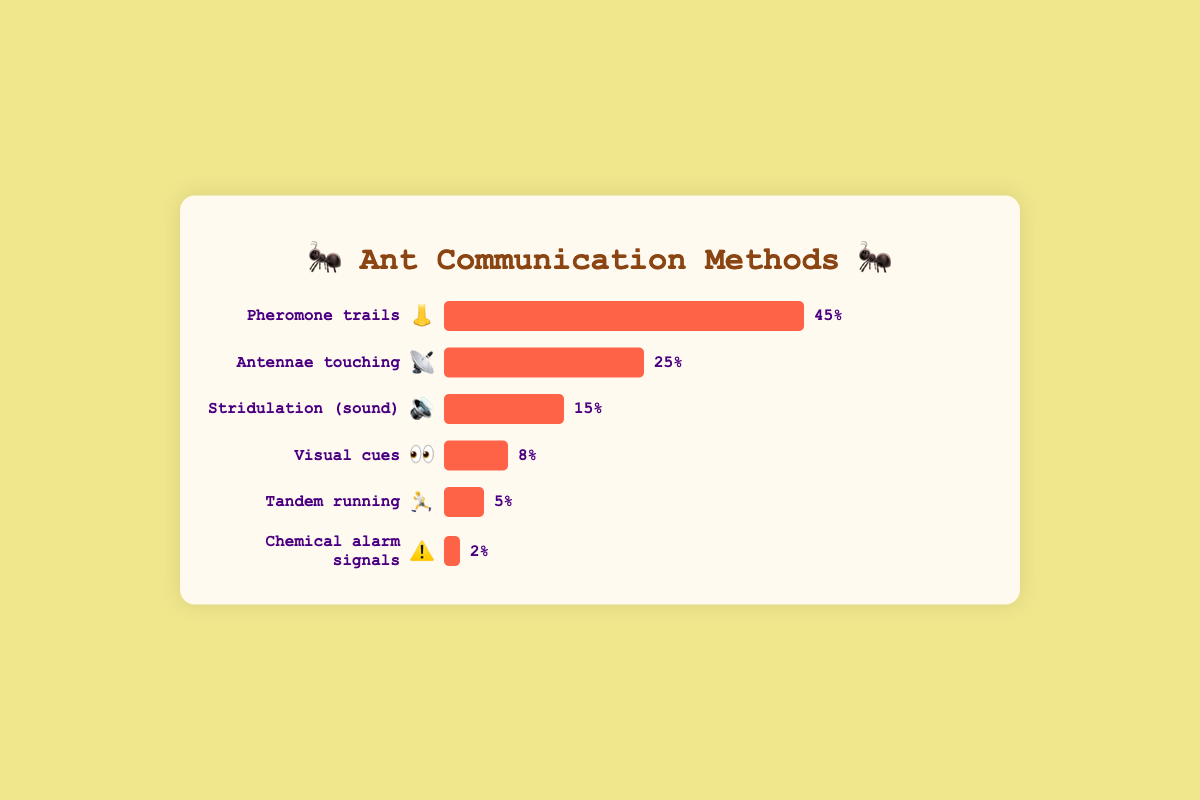What is the most frequently used ant communication method and its corresponding emoji? The data indicates that "Pheromone trails" are the most frequently used ant communication method as it has the highest frequency percentage. The corresponding emoji for "Pheromone trails" is "👃".
Answer: Pheromone trails, 👃 What percentage of communication methods use antennae touching? The data shows that "Antennae touching" is one of the communication methods and its frequency percentage is 25%.
Answer: 25% How much more frequently are pheromone trails used compared to visual cues? "Pheromone trails" are used 45% of the time, while "Visual cues" are used 8% of the time. To find the difference, subtract the lower percentage from the higher percentage: 45% - 8% = 37%.
Answer: 37% Which communication method has the lowest frequency and what is its corresponding emoji? The data indicates "Chemical alarm signals" have the lowest frequency percentage at 2%. The corresponding emoji for "Chemical alarm signals" is "⚠️".
Answer: Chemical alarm signals, ⚠️ How does the frequency of stridulation compare to tandem running? "Stridulation" has a frequency percentage of 15%, whereas "Tandem running" has a frequency percentage of 5%. To compare, subtract the lower value from the higher value: 15% - 5% = 10%.
Answer: Stridulation is 10% more frequent than tandem running What is the sum of the frequencies of visual cues and tandem running? "Visual cues" have a frequency percentage of 8%, and "Tandem running" has a frequency percentage of 5%. Adding these together gives: 8% + 5% = 13%.
Answer: 13% Is the sum of the frequencies of visual cues, tandem running, and chemical alarm signals greater than the frequency of stridulation? "Visual cues" (8%), "Tandem running" (5%), and "Chemical alarm signals" (2%) add up to 8% + 5% + 2% = 15%. The frequency percentage of "Stridulation" is also 15%. Hence, the sum is equal to stridulation frequency.
Answer: No, they are equal Which communication method has an emoji of "📡" and what is its frequency percentage? The data indicates that "Antennae touching" is the communication method with the emoji "📡". The frequency percentage of "Antennae touching" is 25%.
Answer: Antennae touching, 25% What is the combined frequency percentage of the two least used communication methods? The least used communication methods are "Tandem running" with 5% and "Chemical alarm signals" with 2%. Adding these together gives: 5% + 2% = 7%.
Answer: 7% If you combine the frequencies of visual cues, tandem running, and chemical alarm signals, would it be greater than the frequency of antennae touching? "Visual cues" (8%), "Tandem running" (5%), and "Chemical alarm signals" (2%) add up to 8% + 5% + 2% = 15%. "Antennae touching" has a frequency percentage of 25%. Therefore, 15% is less than 25%.
Answer: No 